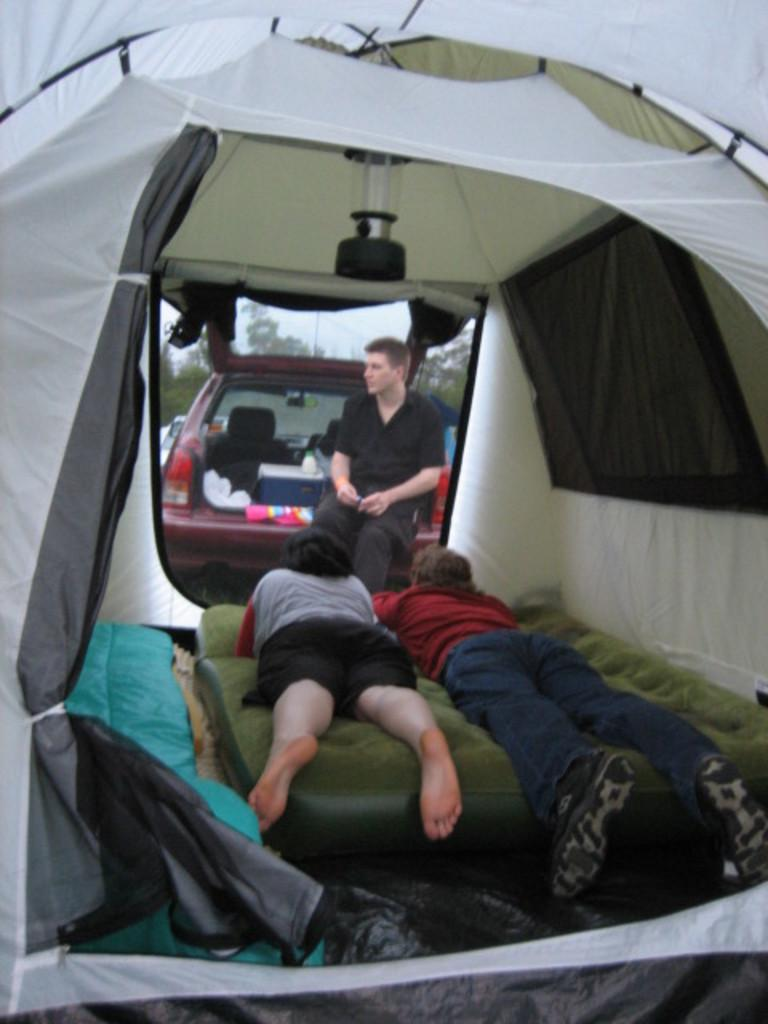What are the two persons doing in the image? The two persons are laying on an air bed in the image. Where is the air bed located? The air bed is inside a tent. What is the man in the image doing? The man is sitting on a car. What color is the shirt the man is wearing? The man is wearing a black color shirt. What type of attraction can be seen in the image? There is no attraction present in the image; it features two persons laying on an air bed inside a tent and a man sitting on a car. How does the oven work in the image? There is no oven present in the image. 